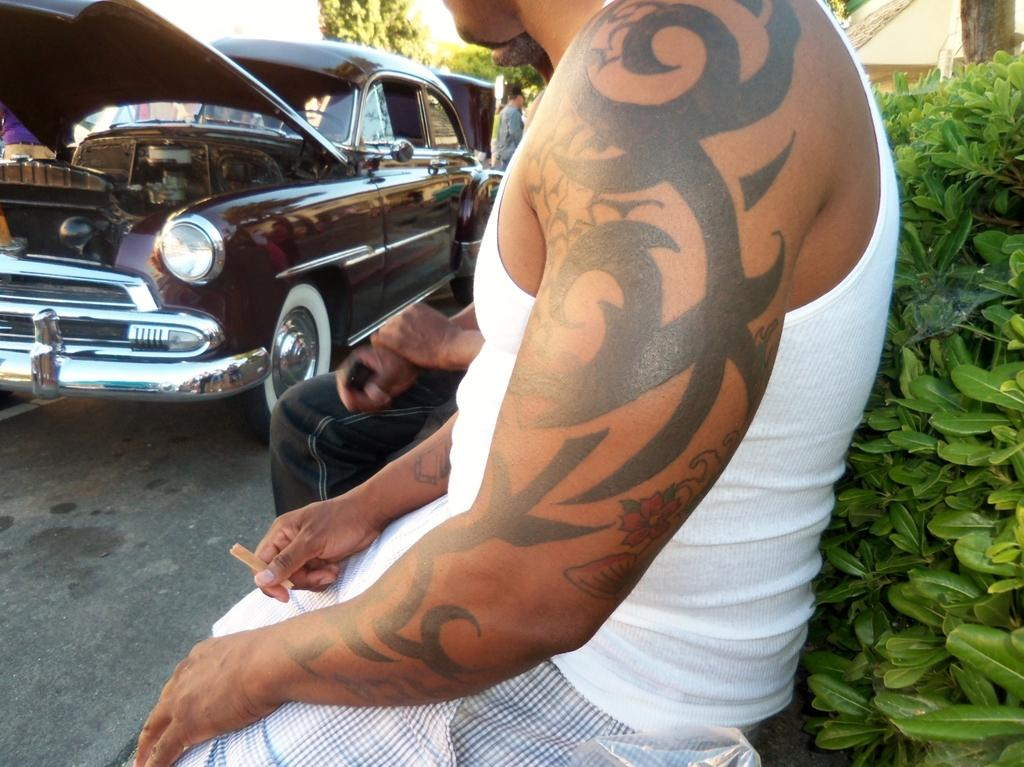Who or what can be seen in the image? There are people in the image. What is on the road in the image? There is a vehicle on the road in the image. What type of living organisms can be seen in the image? Plants are visible in the image. What else can be seen in the image besides people and plants? There are objects in the image. What can be seen in the background of the image? There are trees in the background of the image. What type of cloth is being used by the band in the image? There is no band present in the image, so there is no cloth being used by a band. 